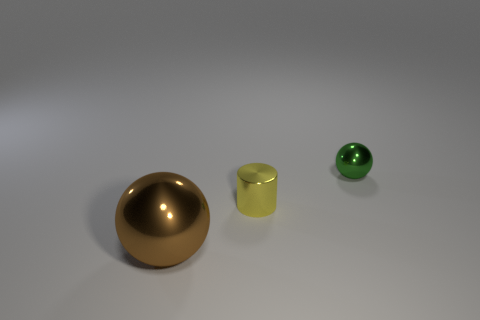How many other brown metallic objects are the same shape as the brown object?
Provide a succinct answer. 0. What number of green things are big objects or big rubber blocks?
Keep it short and to the point. 0. There is a ball that is behind the sphere that is left of the green sphere; what is its size?
Keep it short and to the point. Small. What material is the other green object that is the same shape as the large object?
Your answer should be very brief. Metal. How many other shiny cylinders have the same size as the yellow cylinder?
Ensure brevity in your answer.  0. Do the yellow cylinder and the green metal sphere have the same size?
Your answer should be very brief. Yes. What size is the object that is right of the large ball and left of the green object?
Provide a short and direct response. Small. Is the number of shiny cylinders that are behind the small green metal ball greater than the number of big brown metal balls left of the large sphere?
Offer a very short reply. No. What is the color of the tiny metal thing that is the same shape as the big brown metallic object?
Offer a very short reply. Green. There is a thing that is behind the small yellow cylinder; is its color the same as the cylinder?
Provide a succinct answer. No. 